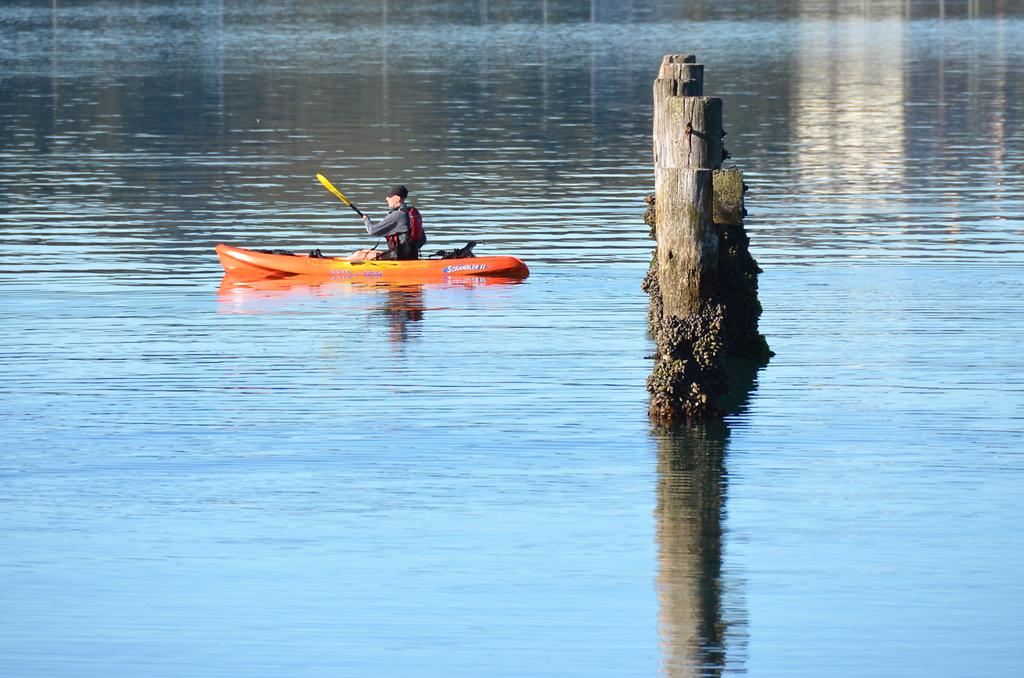What body of water is present in the image? There is a river in the image. What is in the river? There is a boat in the river. Who is in the boat? There is a person sitting in the boat. What object is in the center of the boat? There is a wooden stick in the center of the boat. What type of boot is hanging from the lamp in the image? There is no boot or lamp present in the image. 